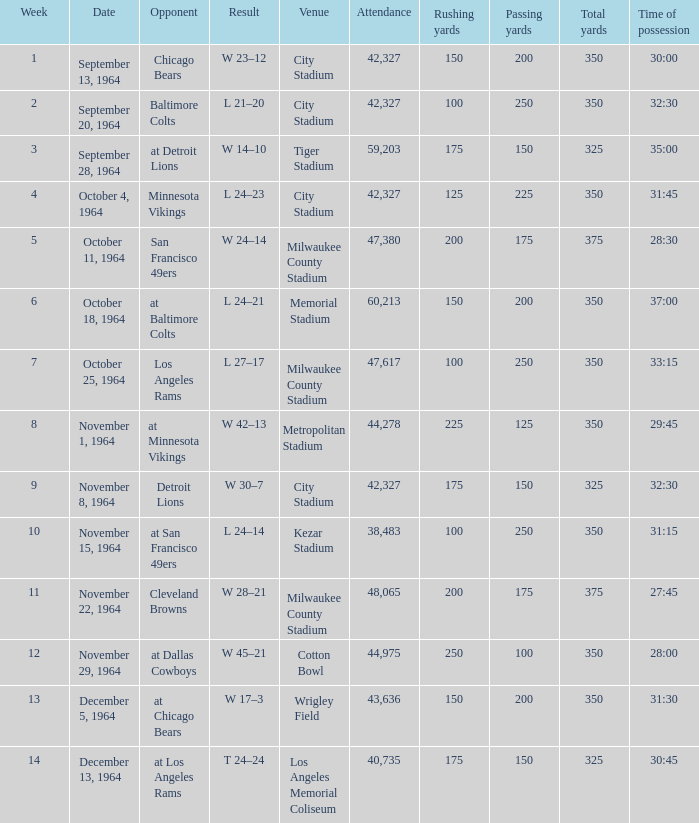What is the average attendance at a week 4 game? 42327.0. 